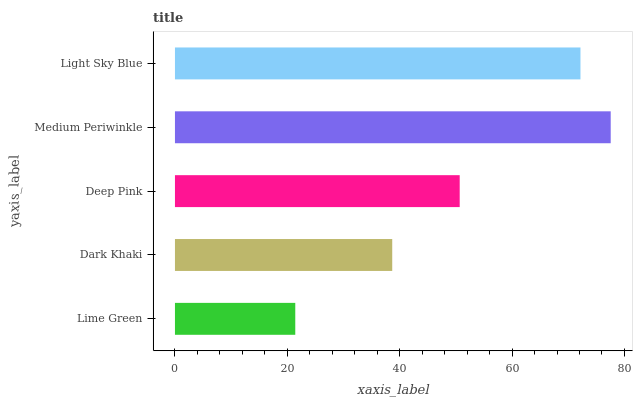Is Lime Green the minimum?
Answer yes or no. Yes. Is Medium Periwinkle the maximum?
Answer yes or no. Yes. Is Dark Khaki the minimum?
Answer yes or no. No. Is Dark Khaki the maximum?
Answer yes or no. No. Is Dark Khaki greater than Lime Green?
Answer yes or no. Yes. Is Lime Green less than Dark Khaki?
Answer yes or no. Yes. Is Lime Green greater than Dark Khaki?
Answer yes or no. No. Is Dark Khaki less than Lime Green?
Answer yes or no. No. Is Deep Pink the high median?
Answer yes or no. Yes. Is Deep Pink the low median?
Answer yes or no. Yes. Is Light Sky Blue the high median?
Answer yes or no. No. Is Medium Periwinkle the low median?
Answer yes or no. No. 